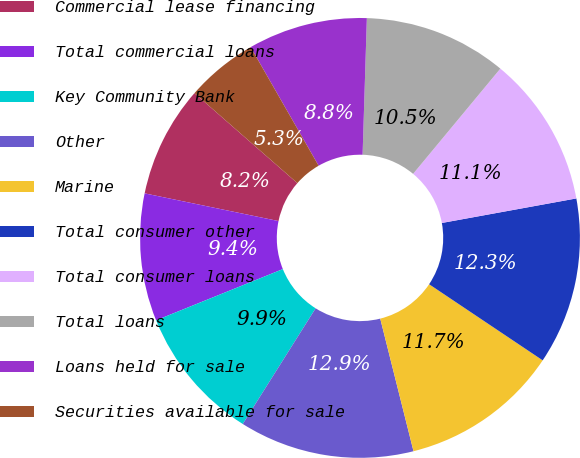Convert chart to OTSL. <chart><loc_0><loc_0><loc_500><loc_500><pie_chart><fcel>Commercial lease financing<fcel>Total commercial loans<fcel>Key Community Bank<fcel>Other<fcel>Marine<fcel>Total consumer other<fcel>Total consumer loans<fcel>Total loans<fcel>Loans held for sale<fcel>Securities available for sale<nl><fcel>8.19%<fcel>9.36%<fcel>9.94%<fcel>12.86%<fcel>11.69%<fcel>12.27%<fcel>11.11%<fcel>10.52%<fcel>8.78%<fcel>5.28%<nl></chart> 